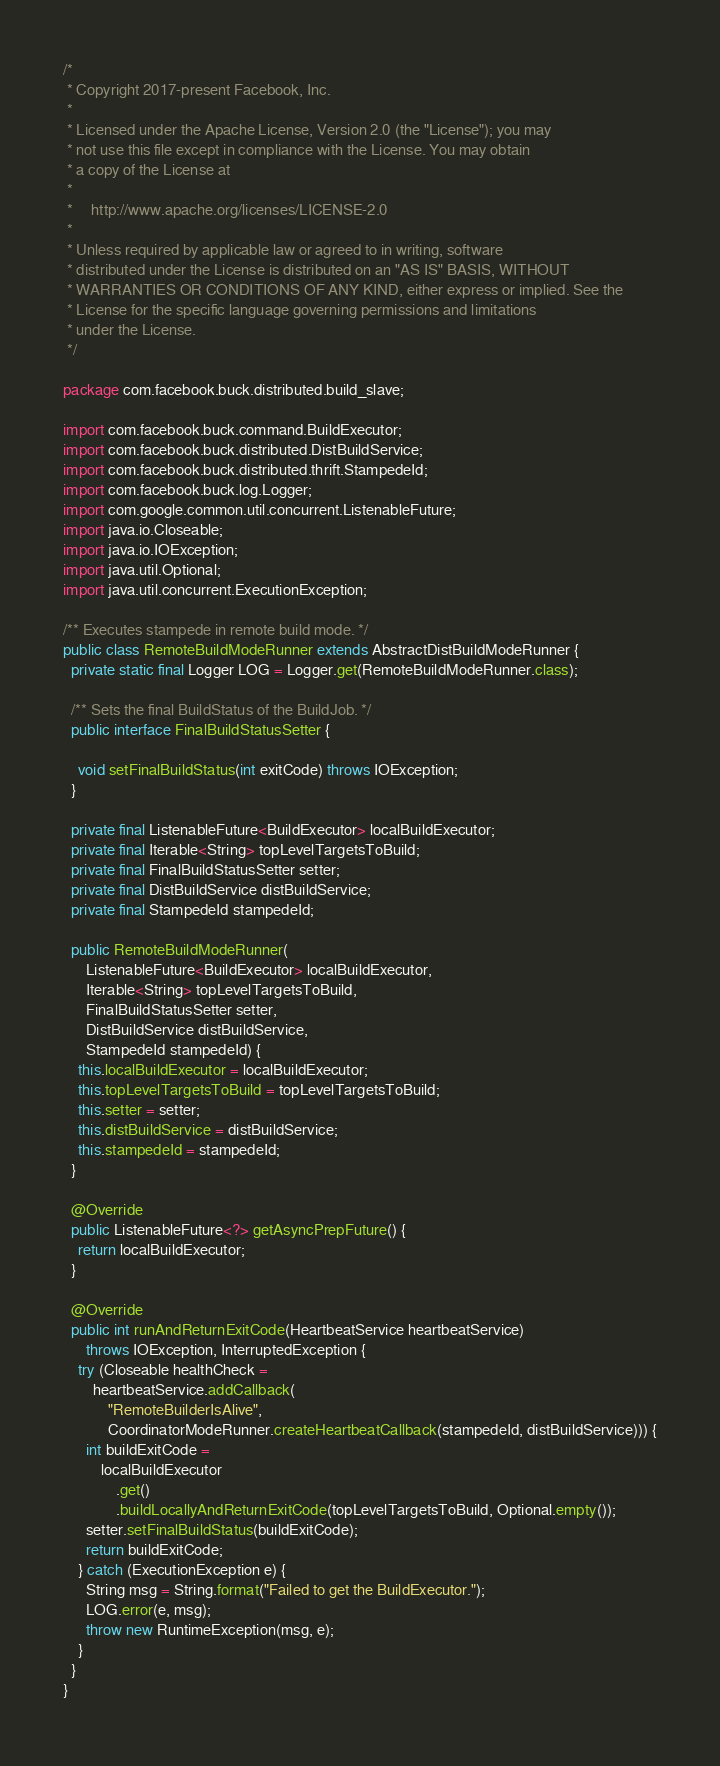<code> <loc_0><loc_0><loc_500><loc_500><_Java_>/*
 * Copyright 2017-present Facebook, Inc.
 *
 * Licensed under the Apache License, Version 2.0 (the "License"); you may
 * not use this file except in compliance with the License. You may obtain
 * a copy of the License at
 *
 *     http://www.apache.org/licenses/LICENSE-2.0
 *
 * Unless required by applicable law or agreed to in writing, software
 * distributed under the License is distributed on an "AS IS" BASIS, WITHOUT
 * WARRANTIES OR CONDITIONS OF ANY KIND, either express or implied. See the
 * License for the specific language governing permissions and limitations
 * under the License.
 */

package com.facebook.buck.distributed.build_slave;

import com.facebook.buck.command.BuildExecutor;
import com.facebook.buck.distributed.DistBuildService;
import com.facebook.buck.distributed.thrift.StampedeId;
import com.facebook.buck.log.Logger;
import com.google.common.util.concurrent.ListenableFuture;
import java.io.Closeable;
import java.io.IOException;
import java.util.Optional;
import java.util.concurrent.ExecutionException;

/** Executes stampede in remote build mode. */
public class RemoteBuildModeRunner extends AbstractDistBuildModeRunner {
  private static final Logger LOG = Logger.get(RemoteBuildModeRunner.class);

  /** Sets the final BuildStatus of the BuildJob. */
  public interface FinalBuildStatusSetter {

    void setFinalBuildStatus(int exitCode) throws IOException;
  }

  private final ListenableFuture<BuildExecutor> localBuildExecutor;
  private final Iterable<String> topLevelTargetsToBuild;
  private final FinalBuildStatusSetter setter;
  private final DistBuildService distBuildService;
  private final StampedeId stampedeId;

  public RemoteBuildModeRunner(
      ListenableFuture<BuildExecutor> localBuildExecutor,
      Iterable<String> topLevelTargetsToBuild,
      FinalBuildStatusSetter setter,
      DistBuildService distBuildService,
      StampedeId stampedeId) {
    this.localBuildExecutor = localBuildExecutor;
    this.topLevelTargetsToBuild = topLevelTargetsToBuild;
    this.setter = setter;
    this.distBuildService = distBuildService;
    this.stampedeId = stampedeId;
  }

  @Override
  public ListenableFuture<?> getAsyncPrepFuture() {
    return localBuildExecutor;
  }

  @Override
  public int runAndReturnExitCode(HeartbeatService heartbeatService)
      throws IOException, InterruptedException {
    try (Closeable healthCheck =
        heartbeatService.addCallback(
            "RemoteBuilderIsAlive",
            CoordinatorModeRunner.createHeartbeatCallback(stampedeId, distBuildService))) {
      int buildExitCode =
          localBuildExecutor
              .get()
              .buildLocallyAndReturnExitCode(topLevelTargetsToBuild, Optional.empty());
      setter.setFinalBuildStatus(buildExitCode);
      return buildExitCode;
    } catch (ExecutionException e) {
      String msg = String.format("Failed to get the BuildExecutor.");
      LOG.error(e, msg);
      throw new RuntimeException(msg, e);
    }
  }
}
</code> 